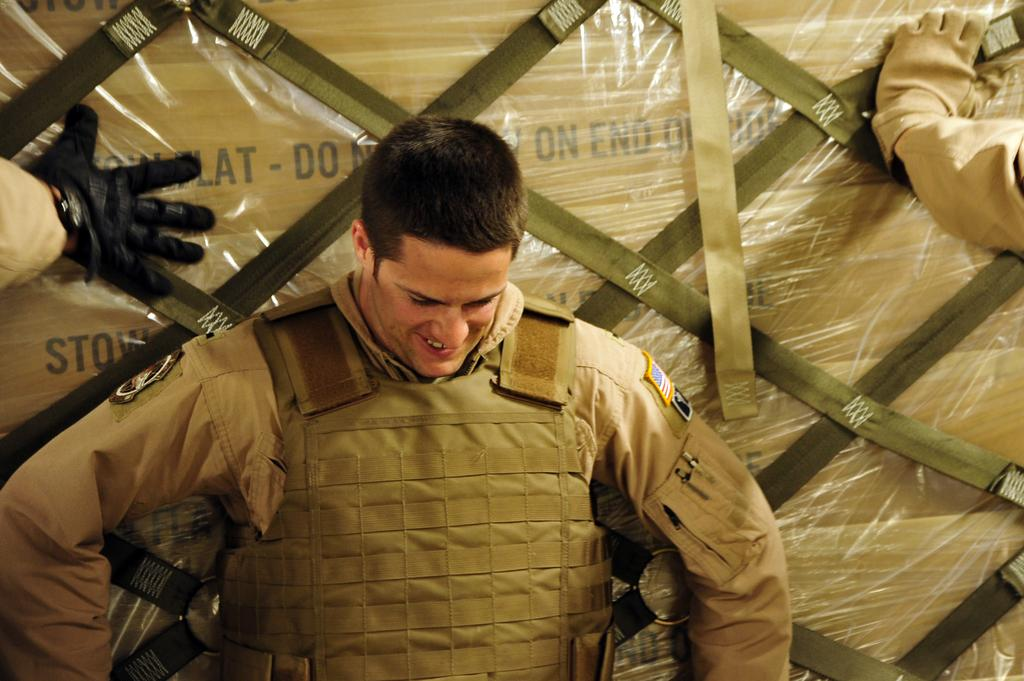What type of person is in the image? There is an army personnel officer in the image. How does the officer appear to be feeling? The officer has a smile on his face. Are there any other officers present in the image? Yes, there are two other officers' hands visible in the image. What are the officers doing in the image? The officers are touching a consignment. How is the consignment being transported or protected? The consignment is packed in a cover. What type of behavior is the scale exhibiting in the image? There is no scale present in the image. How many steps are required for the officer to reach the consignment? The image does not provide information about the distance between the officer and the consignment, so it is impossible to determine the number of steps required. 